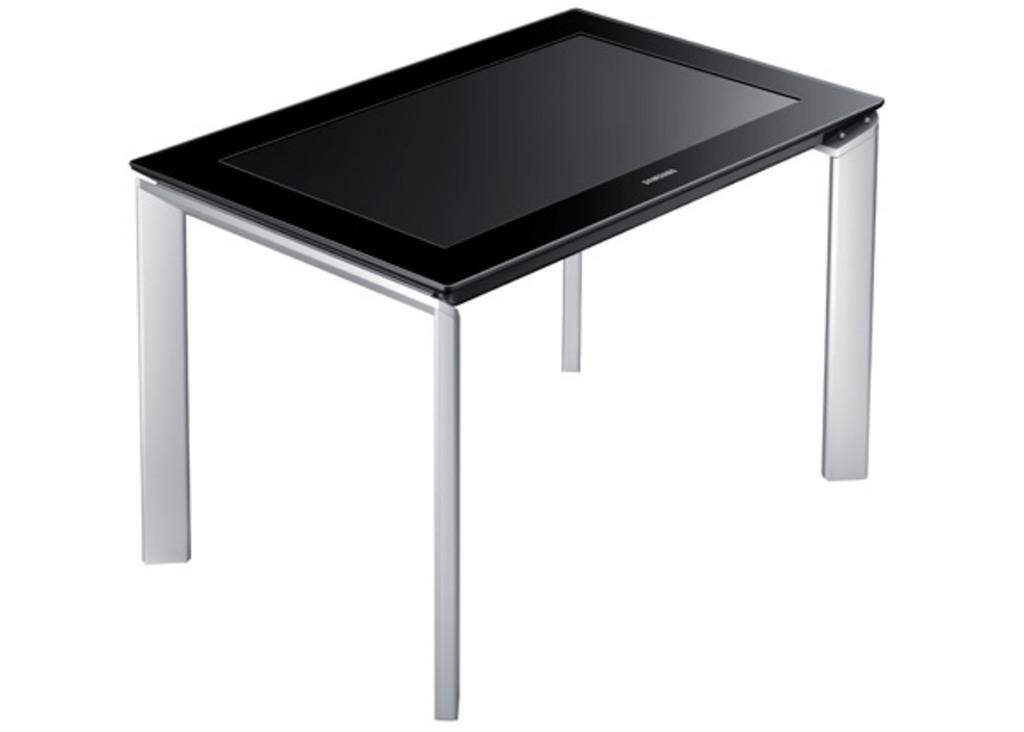What electronic device is present in the image? There is a television in the image. Where is the television placed? The television is on a stand. What type of milk is being poured into the television in the image? There is no milk or pouring action present in the image; it features a television on a stand. What religious symbols can be seen on the television in the image? There are no religious symbols present on the television in the image. 